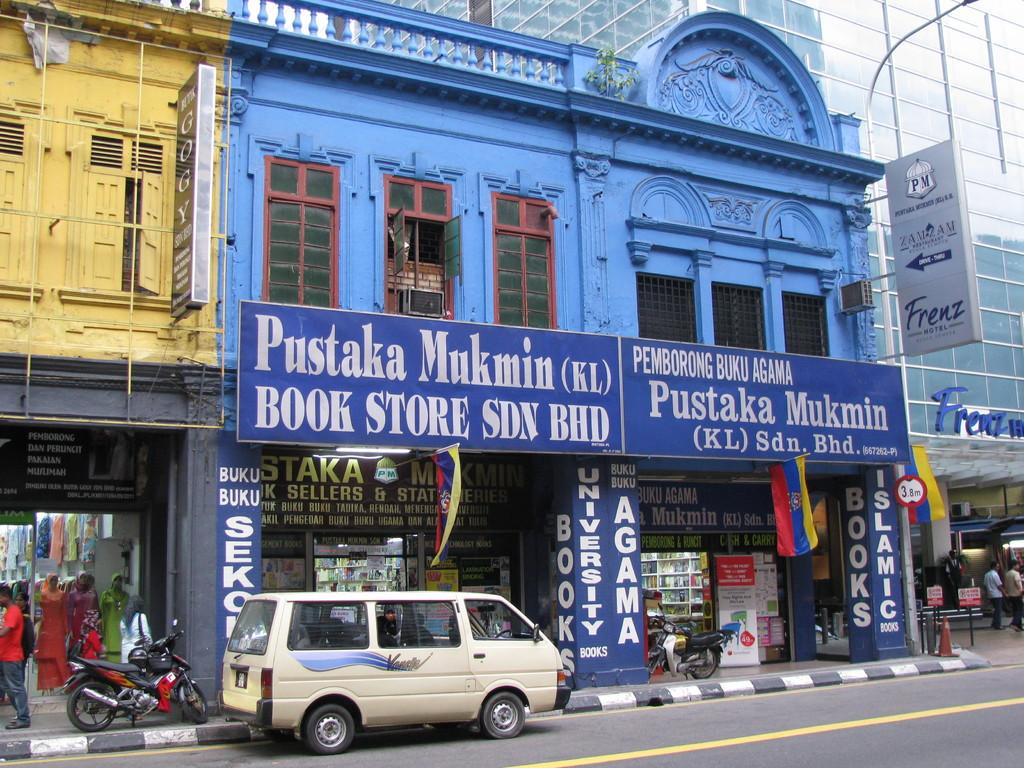Provide a one-sentence caption for the provided image. A Book store on a busy street with a sign that says Pustaka Mukmin. 